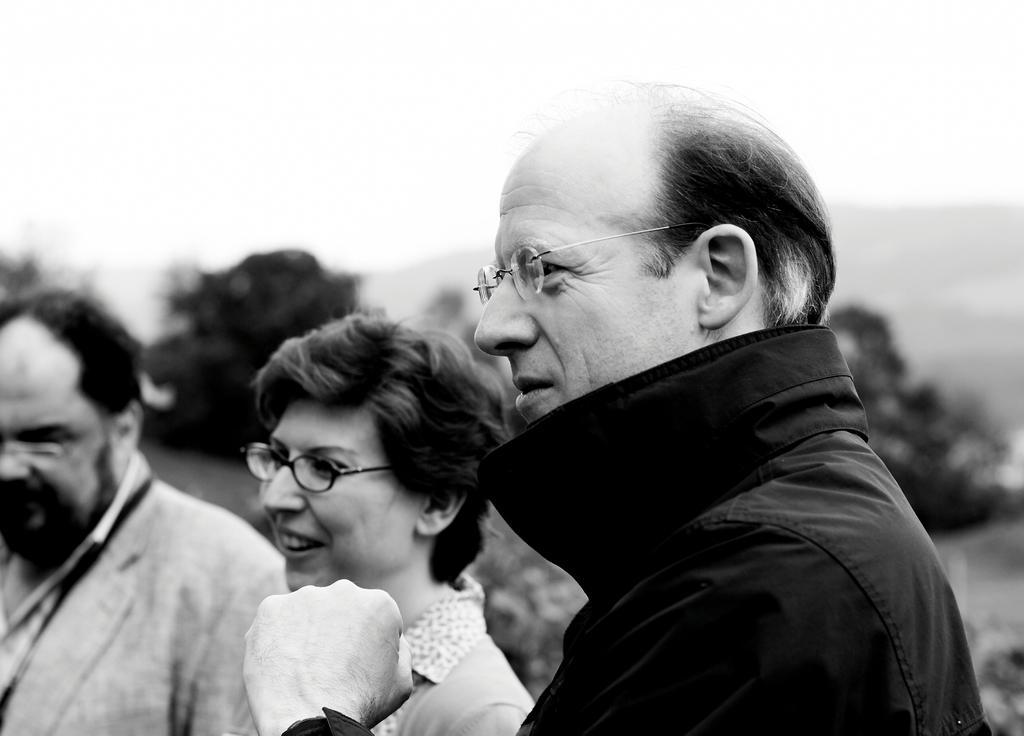In one or two sentences, can you explain what this image depicts? In this black and white image there are three people standing with a smile on their face and looking to the left side of the image. In the background there are trees and the sky. 